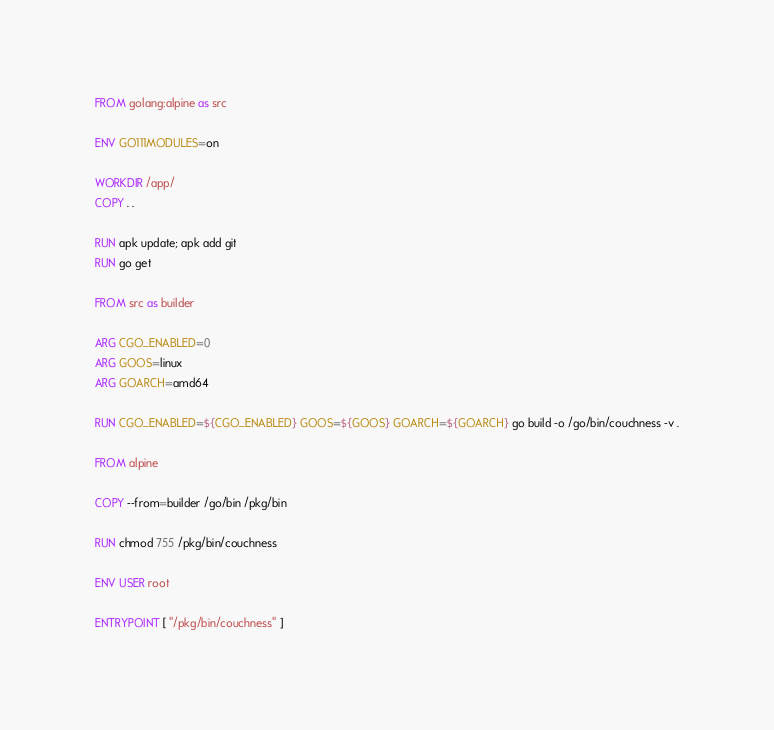<code> <loc_0><loc_0><loc_500><loc_500><_Dockerfile_>FROM golang:alpine as src

ENV GO111MODULES=on

WORKDIR /app/
COPY . .

RUN apk update; apk add git
RUN go get

FROM src as builder 

ARG CGO_ENABLED=0
ARG GOOS=linux
ARG GOARCH=amd64

RUN CGO_ENABLED=${CGO_ENABLED} GOOS=${GOOS} GOARCH=${GOARCH} go build -o /go/bin/couchness -v .

FROM alpine

COPY --from=builder /go/bin /pkg/bin

RUN chmod 755 /pkg/bin/couchness

ENV USER root

ENTRYPOINT [ "/pkg/bin/couchness" ]
</code> 